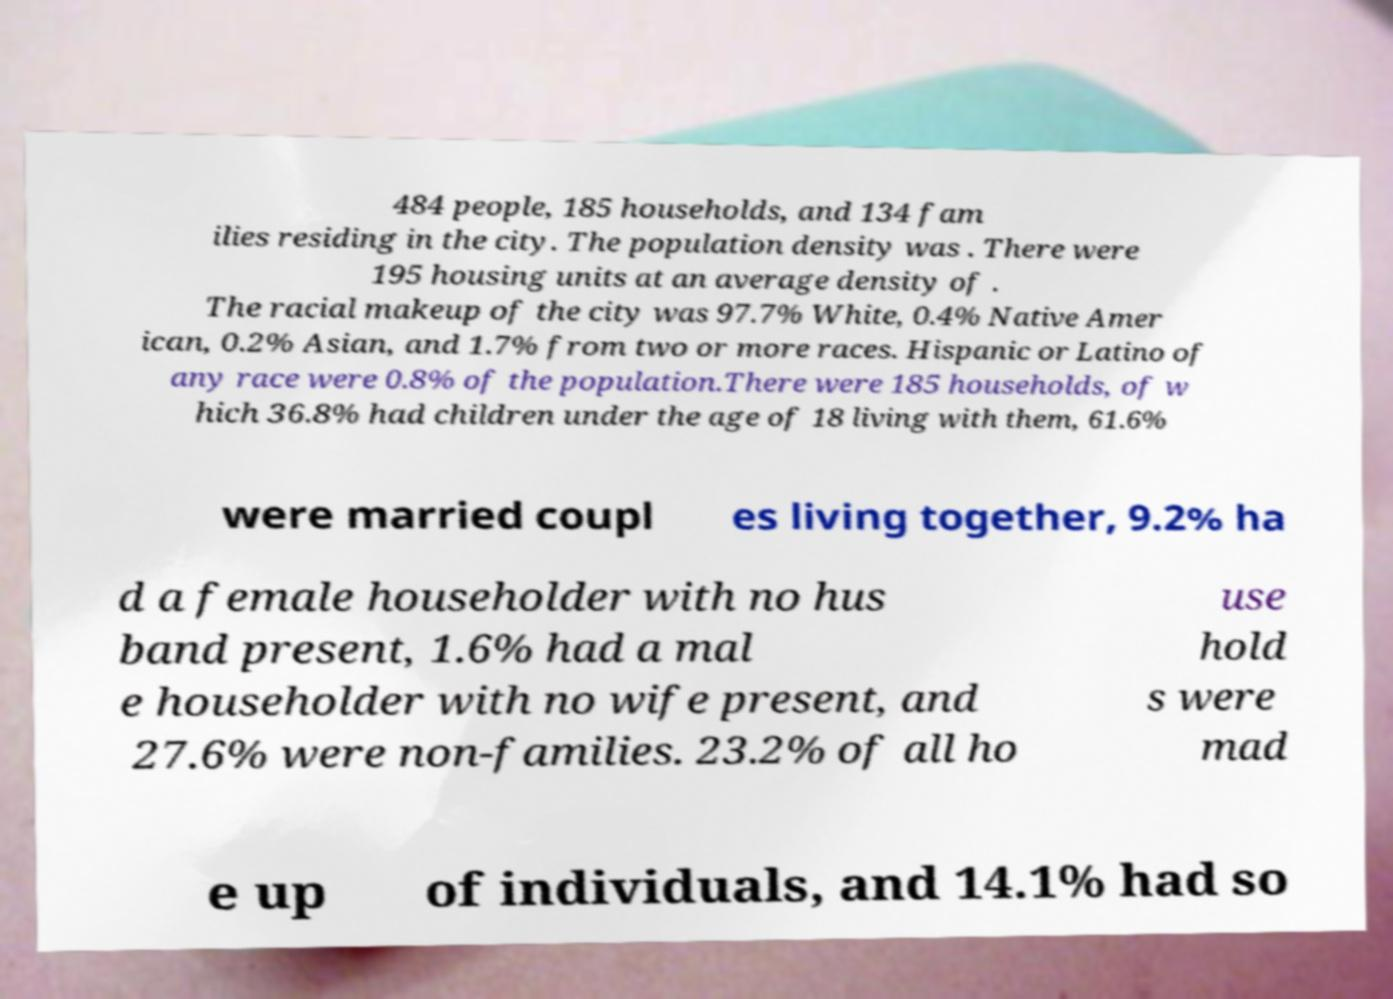Could you assist in decoding the text presented in this image and type it out clearly? 484 people, 185 households, and 134 fam ilies residing in the city. The population density was . There were 195 housing units at an average density of . The racial makeup of the city was 97.7% White, 0.4% Native Amer ican, 0.2% Asian, and 1.7% from two or more races. Hispanic or Latino of any race were 0.8% of the population.There were 185 households, of w hich 36.8% had children under the age of 18 living with them, 61.6% were married coupl es living together, 9.2% ha d a female householder with no hus band present, 1.6% had a mal e householder with no wife present, and 27.6% were non-families. 23.2% of all ho use hold s were mad e up of individuals, and 14.1% had so 